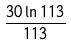<formula> <loc_0><loc_0><loc_500><loc_500>\frac { 3 0 \ln 1 1 3 } { 1 1 3 }</formula> 